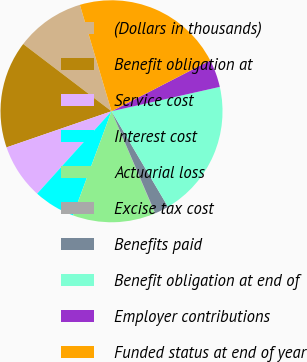Convert chart to OTSL. <chart><loc_0><loc_0><loc_500><loc_500><pie_chart><fcel>(Dollars in thousands)<fcel>Benefit obligation at<fcel>Service cost<fcel>Interest cost<fcel>Actuarial loss<fcel>Excise tax cost<fcel>Benefits paid<fcel>Benefit obligation at end of<fcel>Employer contributions<fcel>Funded status at end of year<nl><fcel>10.04%<fcel>15.64%<fcel>8.04%<fcel>6.04%<fcel>12.04%<fcel>0.05%<fcel>2.05%<fcel>20.03%<fcel>4.05%<fcel>22.03%<nl></chart> 